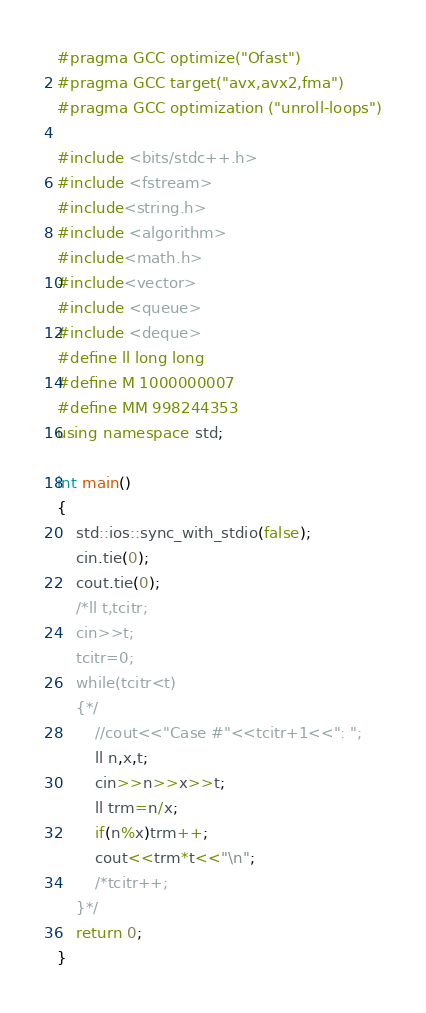Convert code to text. <code><loc_0><loc_0><loc_500><loc_500><_C++_>#pragma GCC optimize("Ofast")
#pragma GCC target("avx,avx2,fma")
#pragma GCC optimization ("unroll-loops")

#include <bits/stdc++.h>
#include <fstream>
#include<string.h>
#include <algorithm>
#include<math.h>
#include<vector>
#include <queue>
#include <deque> 
#define ll long long
#define M 1000000007 
#define MM 998244353
using namespace std;

int main()
{
    std::ios::sync_with_stdio(false);
    cin.tie(0);
    cout.tie(0);
    /*ll t,tcitr;
    cin>>t;
    tcitr=0;
    while(tcitr<t)
    {*/
        //cout<<"Case #"<<tcitr+1<<": ";
        ll n,x,t;
        cin>>n>>x>>t;
        ll trm=n/x;
        if(n%x)trm++;
        cout<<trm*t<<"\n";
        /*tcitr++;
    }*/
    return 0;
}
</code> 